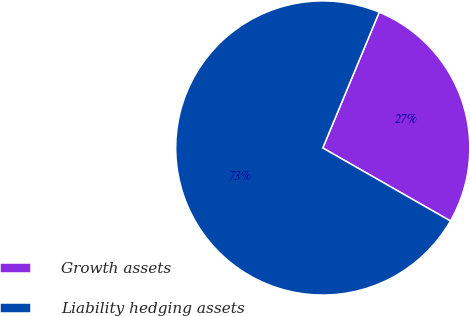Convert chart. <chart><loc_0><loc_0><loc_500><loc_500><pie_chart><fcel>Growth assets<fcel>Liability hedging assets<nl><fcel>27.0%<fcel>73.0%<nl></chart> 